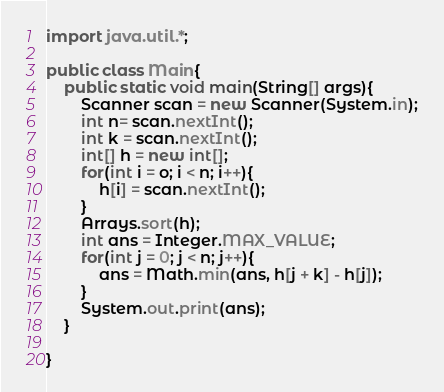<code> <loc_0><loc_0><loc_500><loc_500><_Java_>import java.util.*;
 
public class Main{
	public static void main(String[] args){
    	Scanner scan = new Scanner(System.in);
      	int n= scan.nextInt();
      	int k = scan.nextInt();
      	int[] h = new int[];
     	for(int i = o; i < n; i++){
        	h[i] = scan.nextInt();
        }
      	Arrays.sort(h);
      	int ans = Integer.MAX_VALUE;
      	for(int j = 0; j < n; j++){
        	ans = Math.min(ans, h[j + k] - h[j]);
        }
      	System.out.print(ans);
    }
 
}</code> 